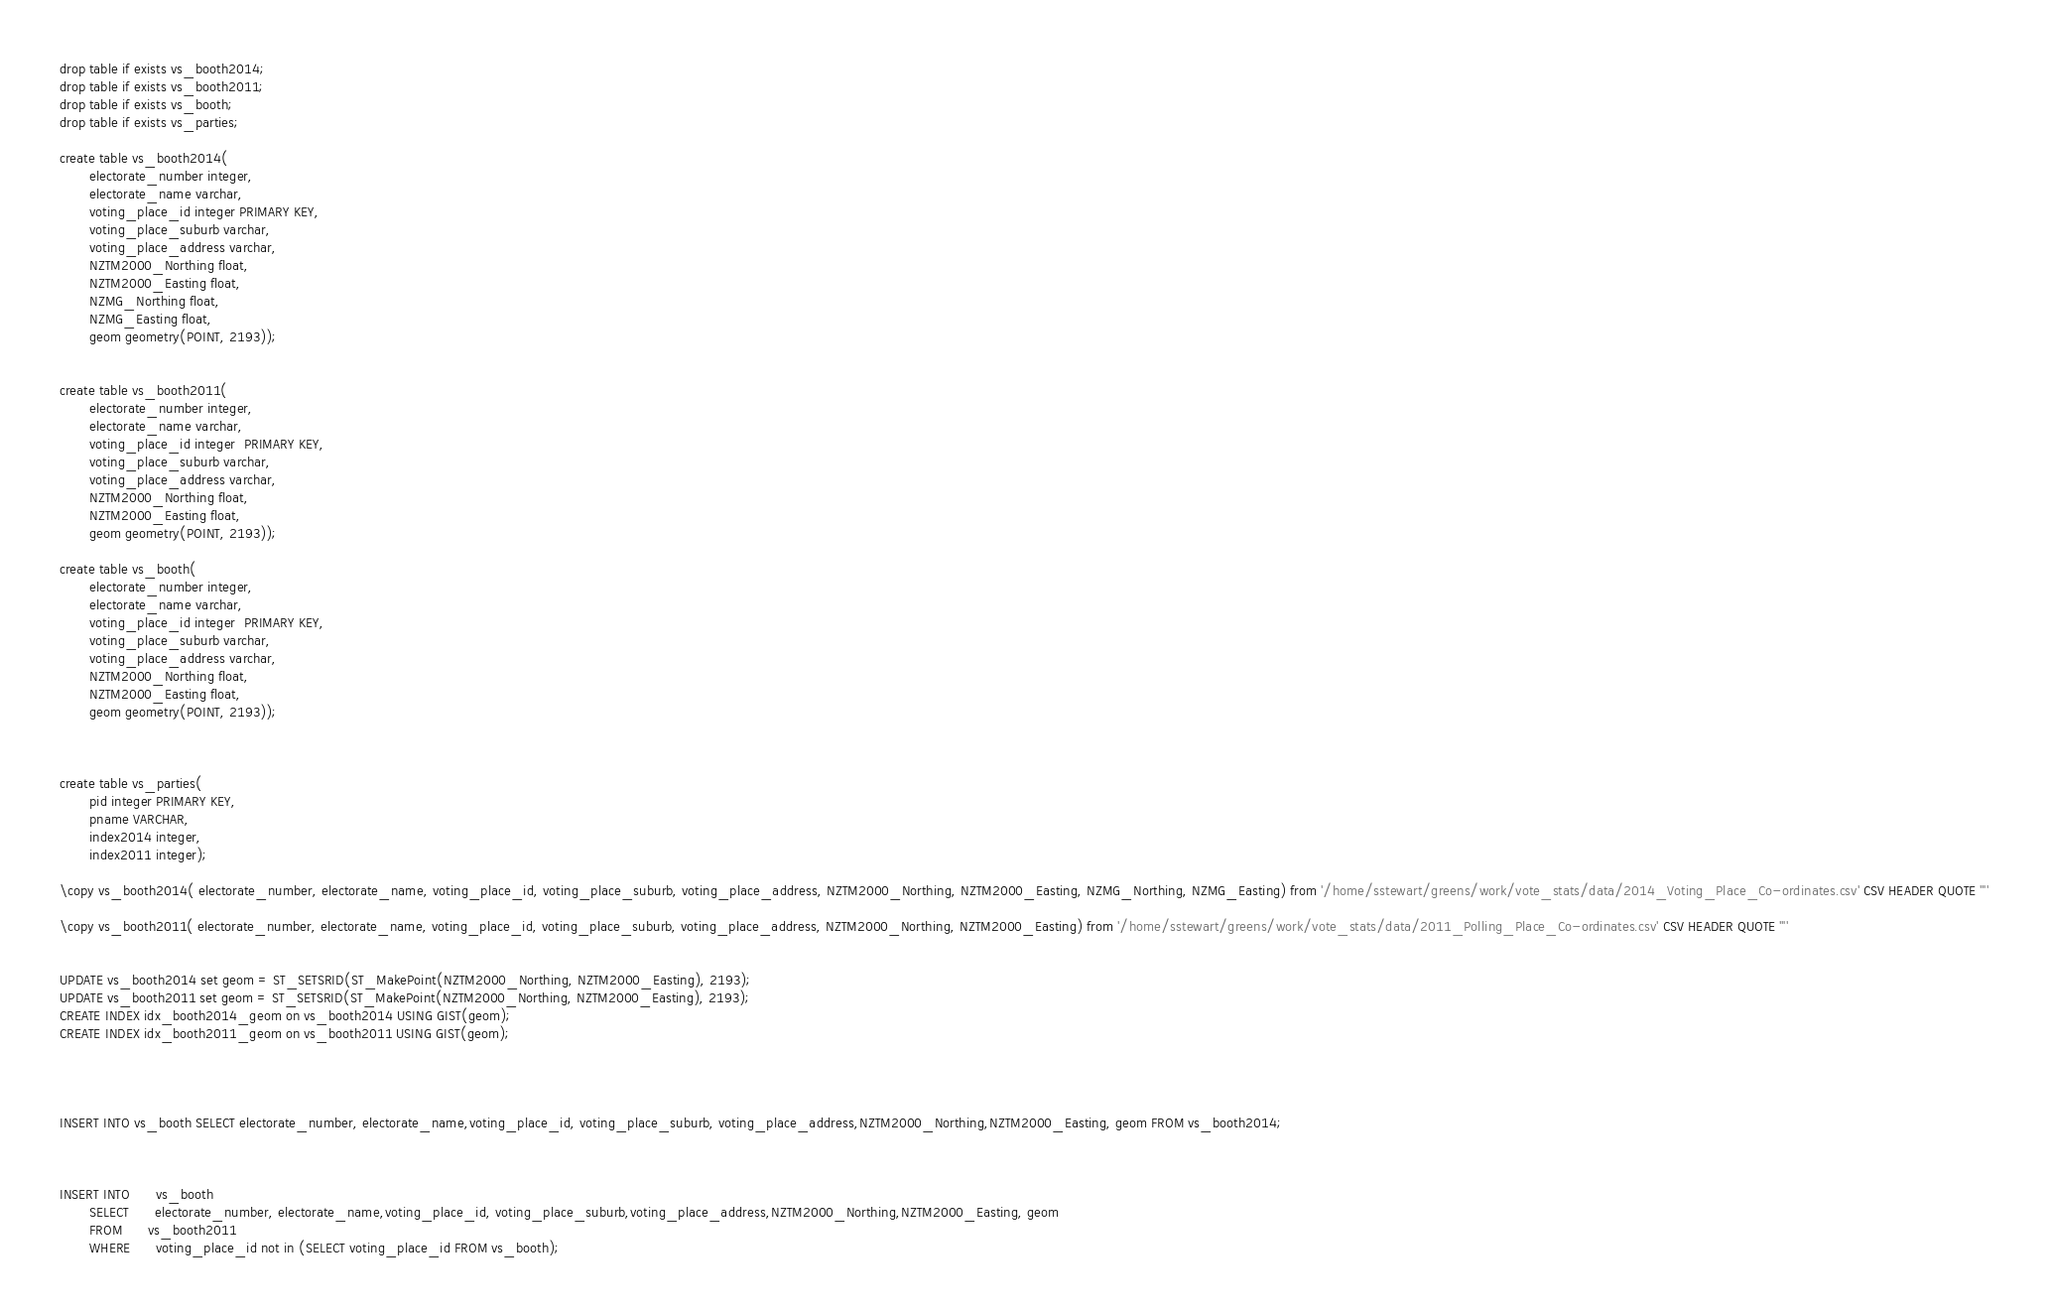Convert code to text. <code><loc_0><loc_0><loc_500><loc_500><_SQL_>drop table if exists vs_booth2014;
drop table if exists vs_booth2011;
drop table if exists vs_booth;
drop table if exists vs_parties;

create table vs_booth2014(
       electorate_number integer,
       electorate_name varchar,
       voting_place_id integer PRIMARY KEY,
       voting_place_suburb varchar,
       voting_place_address varchar,
       NZTM2000_Northing float,
       NZTM2000_Easting float,
       NZMG_Northing float,
       NZMG_Easting float,
       geom geometry(POINT, 2193));


create table vs_booth2011(
       electorate_number integer,
       electorate_name varchar,
       voting_place_id integer  PRIMARY KEY,
       voting_place_suburb varchar,
       voting_place_address varchar,
       NZTM2000_Northing float,
       NZTM2000_Easting float,       
       geom geometry(POINT, 2193));

create table vs_booth(
       electorate_number integer,
       electorate_name varchar,
       voting_place_id integer  PRIMARY KEY,
       voting_place_suburb varchar,
       voting_place_address varchar,
       NZTM2000_Northing float,
       NZTM2000_Easting float,       
       geom geometry(POINT, 2193));



create table vs_parties(
       pid integer PRIMARY KEY,
       pname VARCHAR,
       index2014 integer,
       index2011 integer);

\copy vs_booth2014( electorate_number, electorate_name, voting_place_id, voting_place_suburb, voting_place_address, NZTM2000_Northing, NZTM2000_Easting, NZMG_Northing, NZMG_Easting) from '/home/sstewart/greens/work/vote_stats/data/2014_Voting_Place_Co-ordinates.csv' CSV HEADER QUOTE '"'

\copy vs_booth2011( electorate_number, electorate_name, voting_place_id, voting_place_suburb, voting_place_address, NZTM2000_Northing, NZTM2000_Easting) from '/home/sstewart/greens/work/vote_stats/data/2011_Polling_Place_Co-ordinates.csv' CSV HEADER QUOTE '"'


UPDATE vs_booth2014 set geom = ST_SETSRID(ST_MakePoint(NZTM2000_Northing, NZTM2000_Easting), 2193);
UPDATE vs_booth2011 set geom = ST_SETSRID(ST_MakePoint(NZTM2000_Northing, NZTM2000_Easting), 2193);
CREATE INDEX idx_booth2014_geom on vs_booth2014 USING GIST(geom);
CREATE INDEX idx_booth2011_geom on vs_booth2011 USING GIST(geom);




INSERT INTO vs_booth SELECT electorate_number, electorate_name,voting_place_id, voting_place_suburb, voting_place_address,NZTM2000_Northing,NZTM2000_Easting, geom FROM vs_booth2014;



INSERT INTO 	  vs_booth 
       SELECT 	  electorate_number, electorate_name,voting_place_id, voting_place_suburb,voting_place_address,NZTM2000_Northing,NZTM2000_Easting, geom 
       FROM   	  vs_booth2011
       WHERE 	  voting_place_id not in (SELECT voting_place_id FROM vs_booth);


</code> 